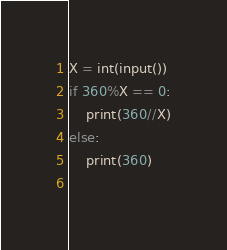Convert code to text. <code><loc_0><loc_0><loc_500><loc_500><_Python_>X = int(input())
if 360%X == 0:
	print(360//X)
else:
	print(360)
	</code> 